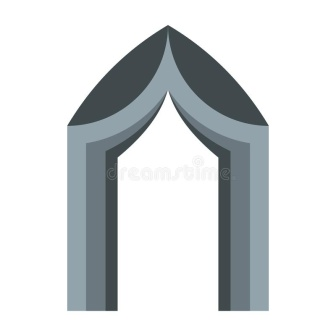Describe the historical significance of structures like the one depicted. Structures similar to the one depicted in the image are reminiscent of Gothic architecture, which flourished in Europe during the High and Late Middle Ages. Characterized by their pointed arches, ribbed vaults, and flying buttresses, these structures were primarily used in the construction of cathedrals and churches. Gothic architecture was not only an expression of religious fervor but also a demonstration of advanced engineering techniques of the time. The pointed arch, as seen in the image, distributed weight more efficiently, allowing for the construction of taller and more stable buildings. These architectural marvels were often adorned with intricate sculptures, stained glass windows, and detailed carvings, serving both a functional and ornamental purpose. They symbolized the ingenuity, artistic expression, and spiritual aspirations of the medieval period. Who might have been the architects of such structures in history? The architects of such Gothic structures were often highly skilled craftsmen and builders, many of whom remain anonymous to history. However, a few prominent names stand out, such as Pierre de Montreuil, who worked on the Notre-Dame Cathedral in Paris, and William of Sens, who contributed to the Canterbury Cathedral in England. These master builders were responsible for designing and overseeing the construction of some of the most magnificent buildings of the Middle Ages. Their work involved not just architectural design, but also coordination of numerous artisans, including masons, sculptors, and glassmakers, thus reflecting a collaborative effort in the creation of these monumental structures. Imagine this archway within a bustling medieval city. Describe the scene in detail. The gray archway, with its pointed apex, stands proudly at the entrance to a bustling medieval city. Surrounding the archway, the cobblestone streets are alive with activity. Merchants peddle their wares from wooden stalls, offering everything from fresh produce to finely woven textiles. The scent of freshly baked bread mingles with the aroma of herbs and spices, creating a heady fragrance that permeates the air. Citizens clad in simple woolen garments and leather shoes navigate the crowded streets, engaging in lively conversation. Children dart about, playing games and chasing each other with infectious laughter. Horses and carts weave through the throng, their hoofbeats and wooden wheels adding a rhythmic backdrop to the city’s symphony. 